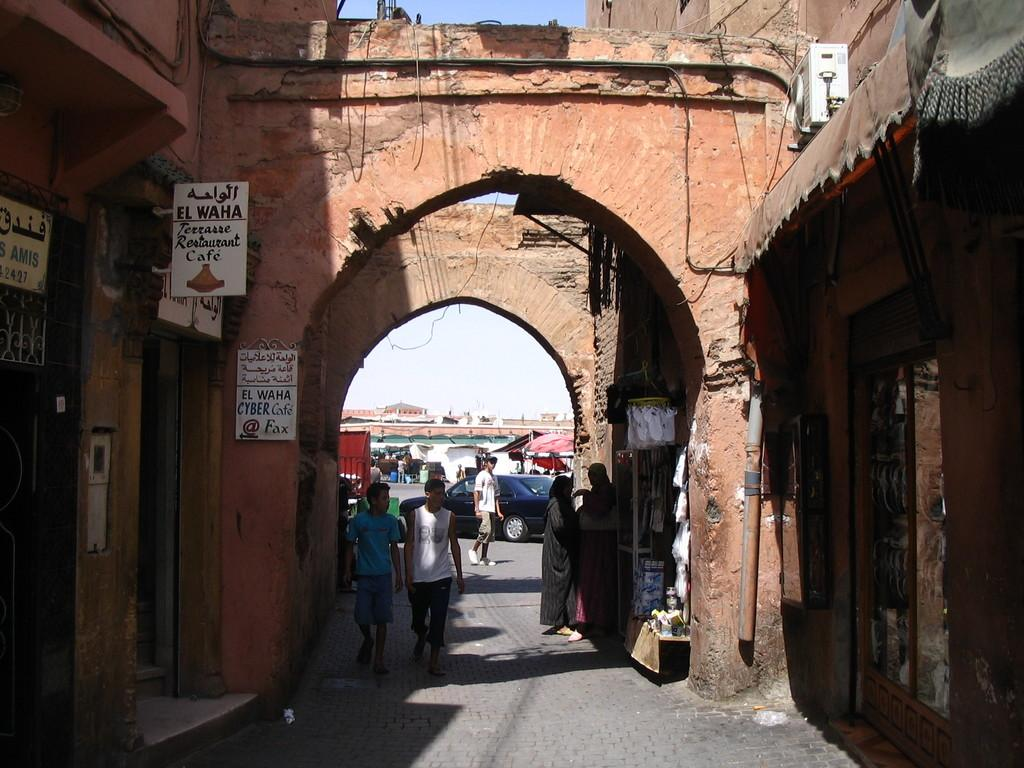What is located at the bottom of the image? There is a crowd at the bottom of the image. What can be seen on the road in the image? Vehicles are present on the road. What type of structures are visible in the background of the image? There are buildings, restaurants, and tents in the background of the image. What is visible in the sky in the image? The sky is visible in the image. When was the image taken? The image was taken during the day. What type of elbow is visible in the image in the image? There is no elbow present in the image. What type of sail can be seen in the image? There is no sail present in the image. 